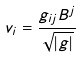<formula> <loc_0><loc_0><loc_500><loc_500>v _ { i } = \frac { g _ { i j } B ^ { j } } { \sqrt { | g | } }</formula> 